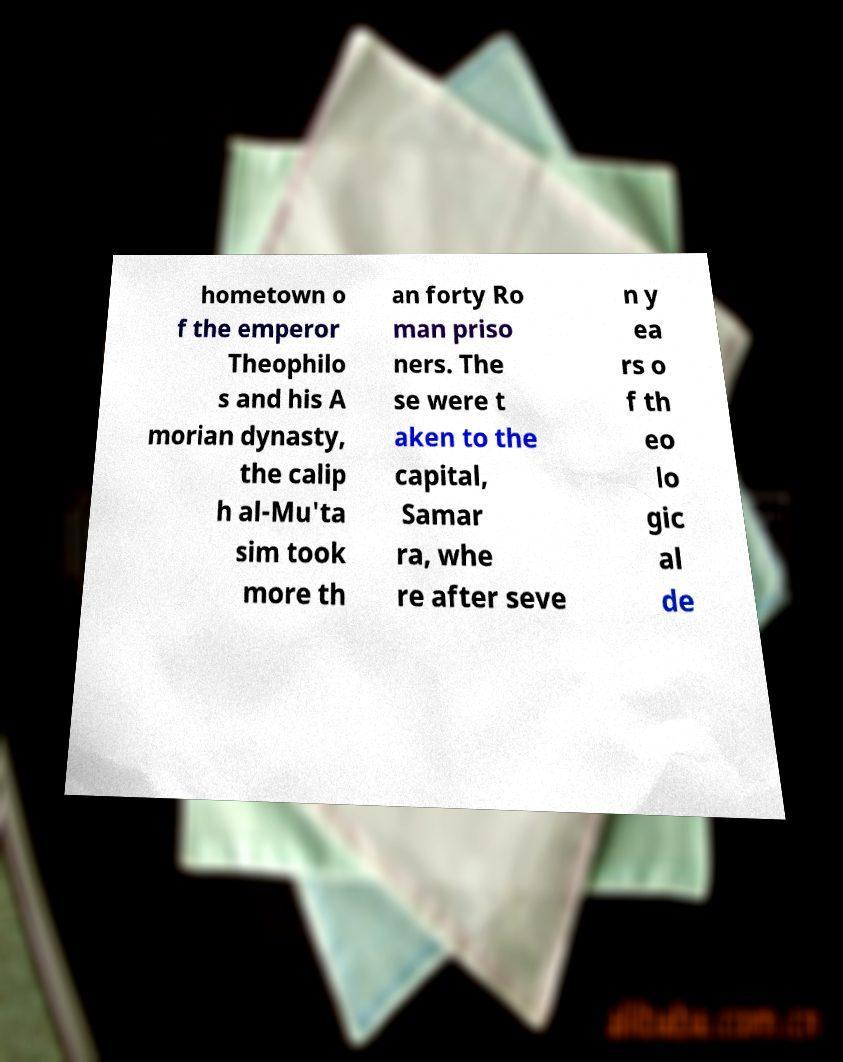I need the written content from this picture converted into text. Can you do that? hometown o f the emperor Theophilo s and his A morian dynasty, the calip h al-Mu'ta sim took more th an forty Ro man priso ners. The se were t aken to the capital, Samar ra, whe re after seve n y ea rs o f th eo lo gic al de 